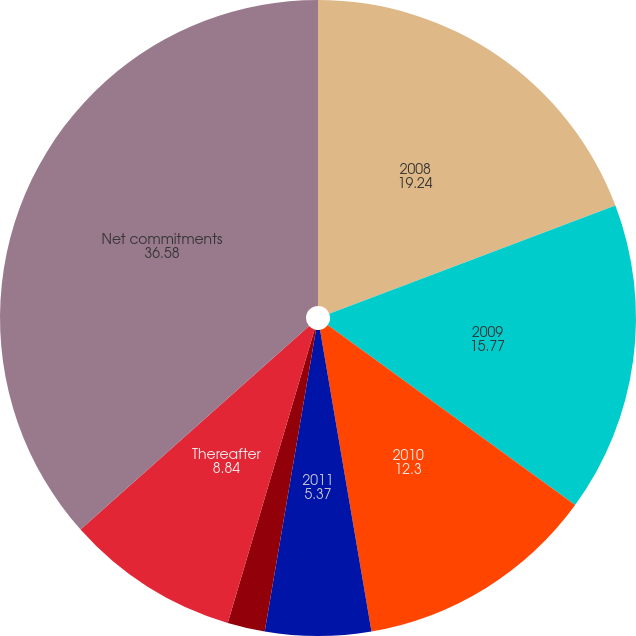Convert chart. <chart><loc_0><loc_0><loc_500><loc_500><pie_chart><fcel>2008<fcel>2009<fcel>2010<fcel>2011<fcel>2012<fcel>Thereafter<fcel>Net commitments<nl><fcel>19.24%<fcel>15.77%<fcel>12.3%<fcel>5.37%<fcel>1.9%<fcel>8.84%<fcel>36.58%<nl></chart> 